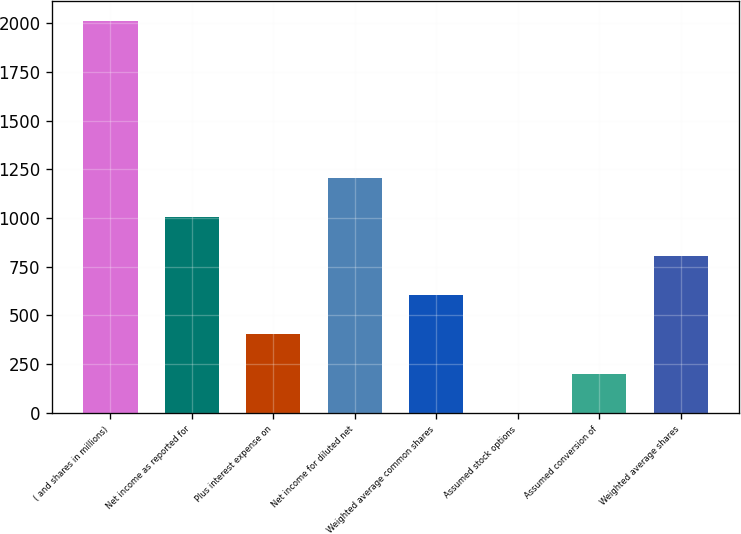<chart> <loc_0><loc_0><loc_500><loc_500><bar_chart><fcel>( and shares in millions)<fcel>Net income as reported for<fcel>Plus interest expense on<fcel>Net income for diluted net<fcel>Weighted average common shares<fcel>Assumed stock options<fcel>Assumed conversion of<fcel>Weighted average shares<nl><fcel>2011<fcel>1005.7<fcel>402.52<fcel>1206.76<fcel>603.58<fcel>0.4<fcel>201.46<fcel>804.64<nl></chart> 